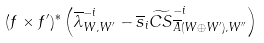<formula> <loc_0><loc_0><loc_500><loc_500>( f \times f ^ { \prime } ) ^ { * } \left ( \overline { \lambda } ^ { - i } _ { W , W ^ { \prime } } - \overline { s } _ { i } \widetilde { C S } ^ { - i } _ { \overline { A } ( W \oplus W ^ { \prime } ) , W ^ { \prime \prime } } \right )</formula> 